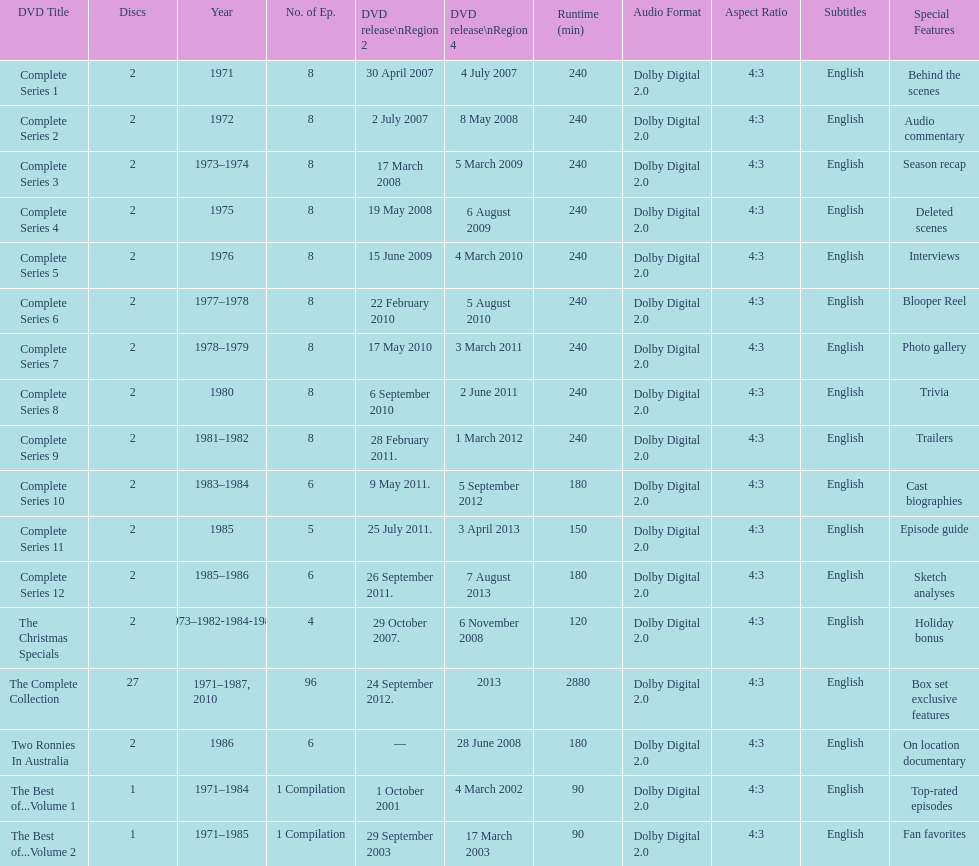True or false. the television show "the two ronnies" featured more than 10 episodes in a season. False. 